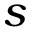Convert formula to latex. <formula><loc_0><loc_0><loc_500><loc_500>s</formula> 